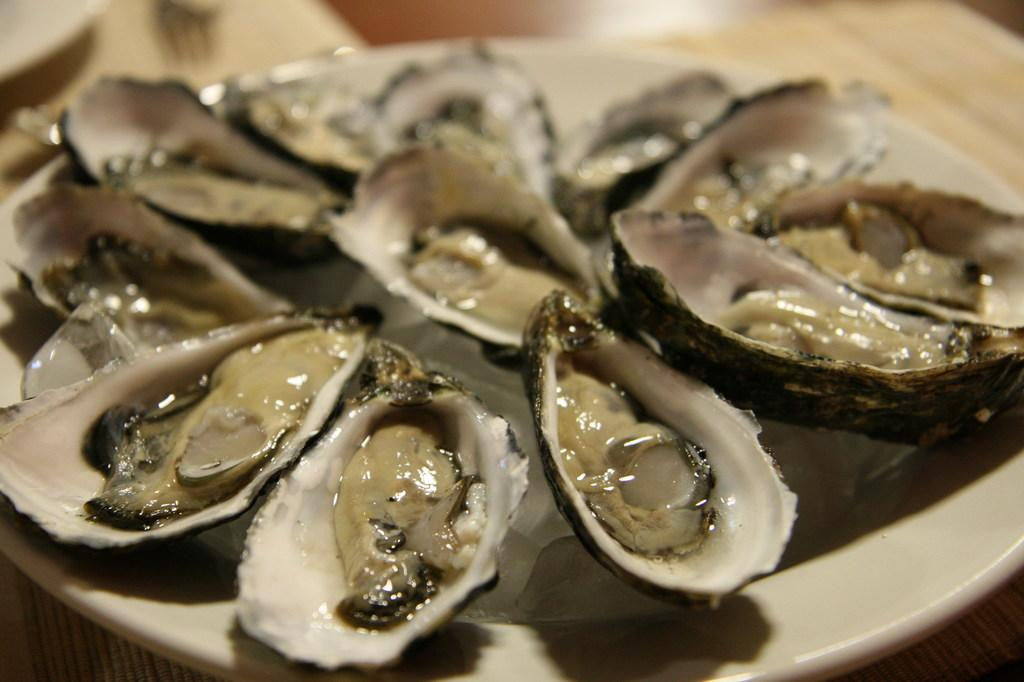What object is present on the table in the image? There is a plate on the table in the image. What is the plate resting on? The plate is on a table. What can be found on top of the plate? There is a food item on the plate. What type of learning material is visible on the plate in the image? There is no learning material present on the plate in the image; it contains a food item. 